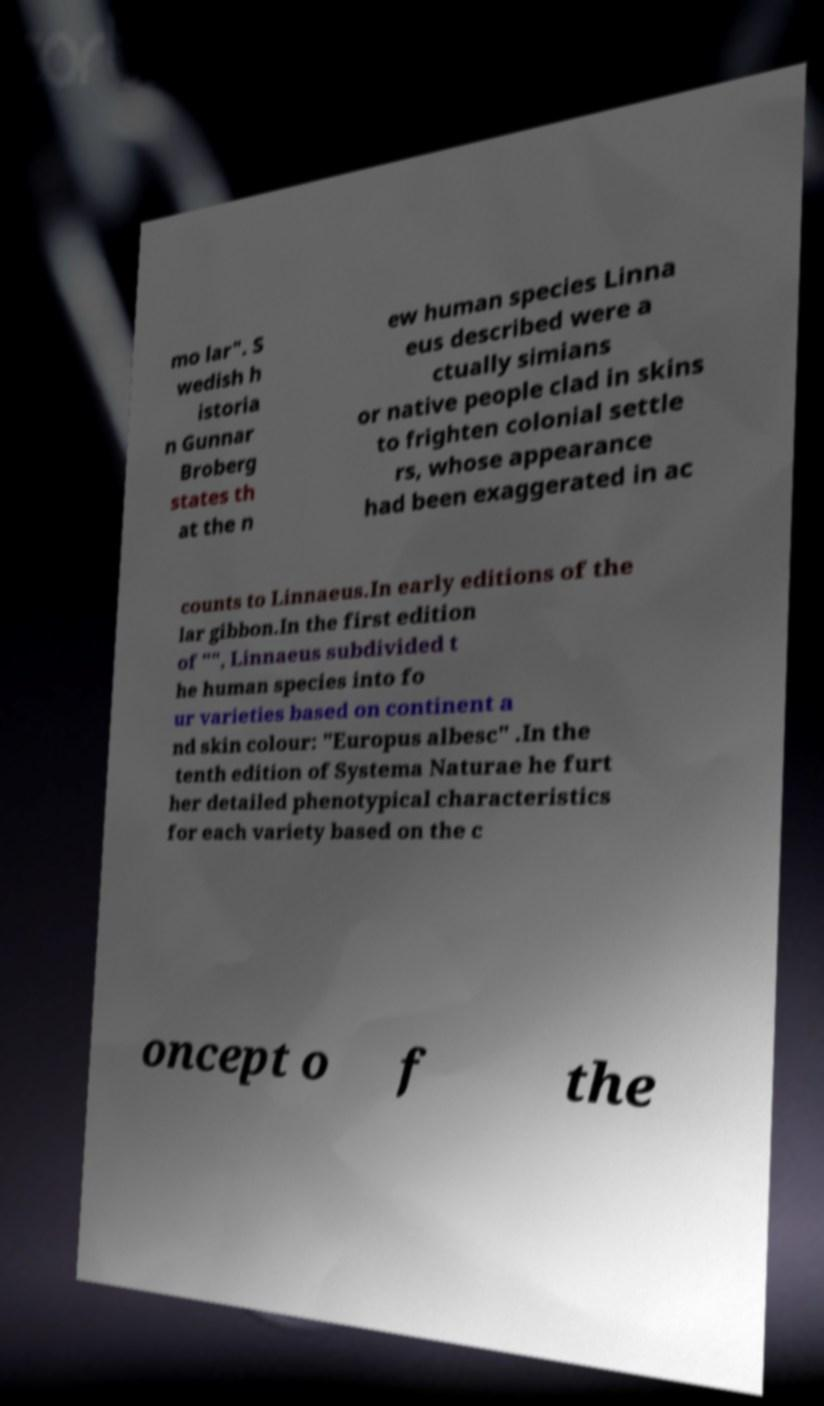I need the written content from this picture converted into text. Can you do that? mo lar". S wedish h istoria n Gunnar Broberg states th at the n ew human species Linna eus described were a ctually simians or native people clad in skins to frighten colonial settle rs, whose appearance had been exaggerated in ac counts to Linnaeus.In early editions of the lar gibbon.In the first edition of "", Linnaeus subdivided t he human species into fo ur varieties based on continent a nd skin colour: "Europus albesc" .In the tenth edition of Systema Naturae he furt her detailed phenotypical characteristics for each variety based on the c oncept o f the 